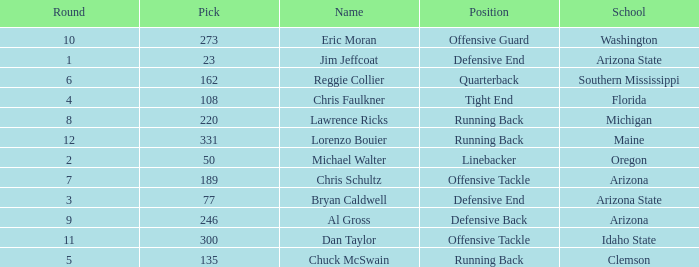What is the largest pick in round 8? 220.0. 